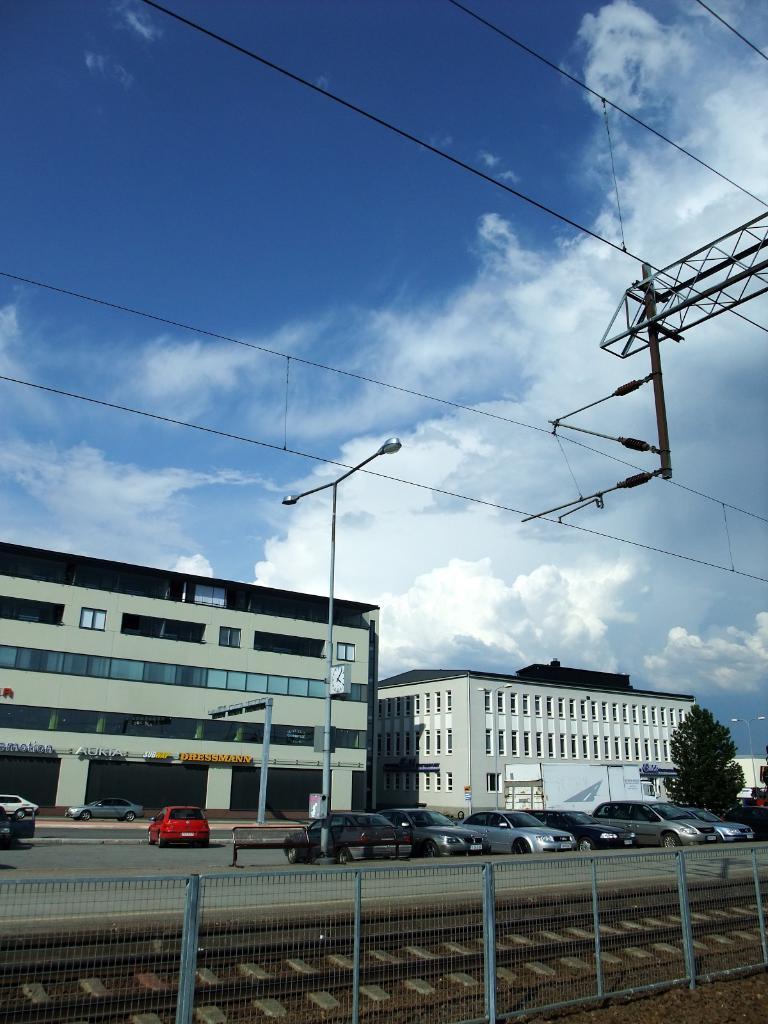Please provide a concise description of this image. Sky is cloudy. These are light poles. Here we can see fence, train track, vehicles and tree. Background there are buildings with windows. 